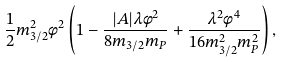<formula> <loc_0><loc_0><loc_500><loc_500>\frac { 1 } { 2 } m _ { 3 / 2 } ^ { 2 } \phi ^ { 2 } \left ( 1 - \frac { | A | \lambda \phi ^ { 2 } } { 8 m _ { 3 / 2 } m _ { P } } + \frac { \lambda ^ { 2 } \phi ^ { 4 } } { 1 6 m _ { 3 / 2 } ^ { 2 } m _ { P } ^ { 2 } } \right ) ,</formula> 